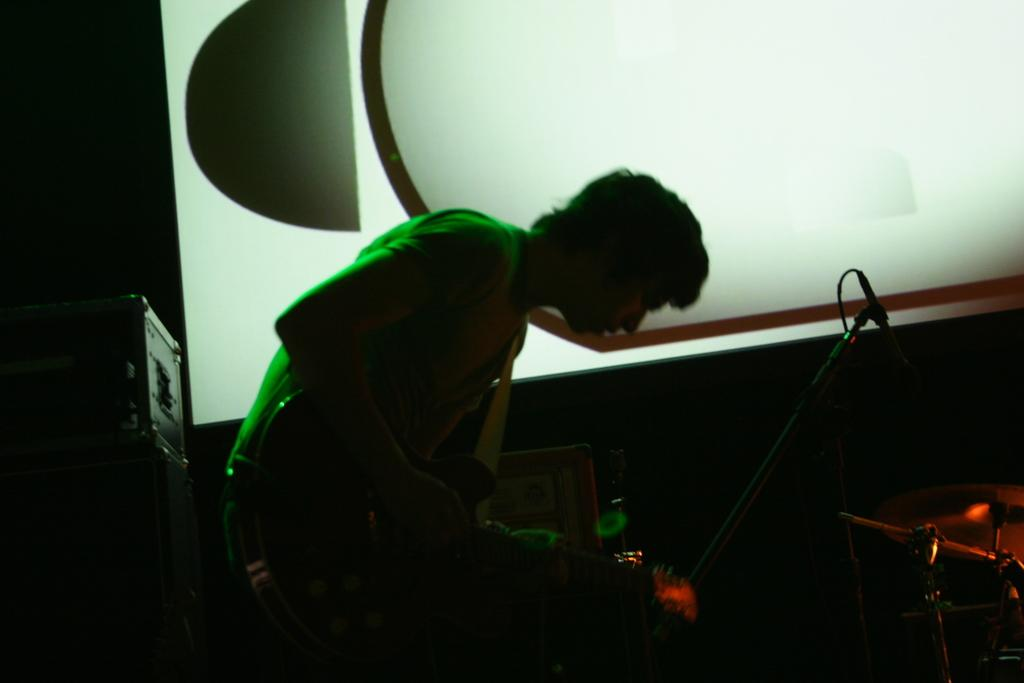Who is the main subject in the image? There is a person in the image. What is the person holding in the image? The person is holding a guitar. What is in front of the person that might be used for amplifying sound? There is a microphone in front of the person. What other musical instruments are present in the image? There are other musical instruments in front of the person. What electronic device is located beside the person? There is an LCD screen beside the person. What type of tin can be seen in the person's pocket in the image? There is no tin visible in the person's pocket in the image. Is the person in the image being held in a prison? There is no indication in the image that the person is in a prison. 